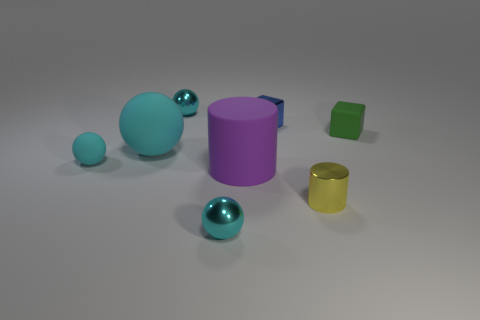Subtract all cyan spheres. How many were subtracted if there are1cyan spheres left? 3 Subtract all blocks. How many objects are left? 6 Add 2 big green metallic objects. How many objects exist? 10 Subtract all cyan matte cubes. Subtract all matte things. How many objects are left? 4 Add 5 shiny cylinders. How many shiny cylinders are left? 6 Add 2 brown objects. How many brown objects exist? 2 Subtract 0 cyan cylinders. How many objects are left? 8 